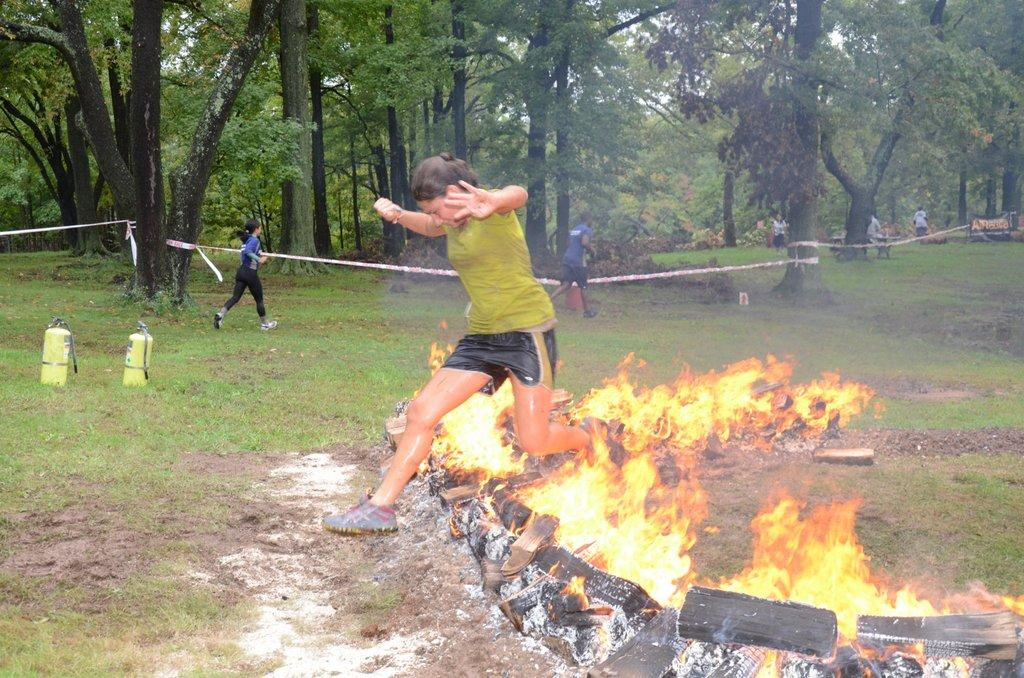Who is the main subject in the foreground of the image? There is a woman in the foreground of the image. What is the woman doing in the image? The woman is jumping up from a fire. What can be seen in the background of the image? In the background, there are persons running, grass, cylinders, and trees. What type of apples are being used as a power source for the instrument in the image? There are no apples or instruments present in the image. 